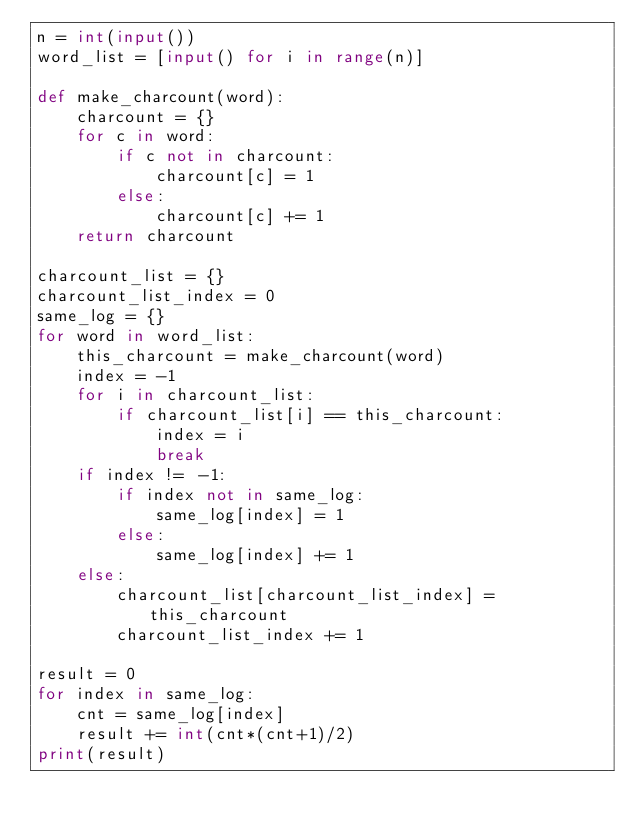<code> <loc_0><loc_0><loc_500><loc_500><_Python_>n = int(input())
word_list = [input() for i in range(n)]

def make_charcount(word):
    charcount = {}
    for c in word:
        if c not in charcount:
            charcount[c] = 1
        else:
            charcount[c] += 1
    return charcount

charcount_list = {}
charcount_list_index = 0
same_log = {}
for word in word_list:
    this_charcount = make_charcount(word)
    index = -1
    for i in charcount_list:
        if charcount_list[i] == this_charcount:
            index = i
            break
    if index != -1:
        if index not in same_log:
            same_log[index] = 1
        else:
            same_log[index] += 1
    else:
        charcount_list[charcount_list_index] = this_charcount
        charcount_list_index += 1
        
result = 0
for index in same_log:
    cnt = same_log[index]
    result += int(cnt*(cnt+1)/2)
print(result)</code> 